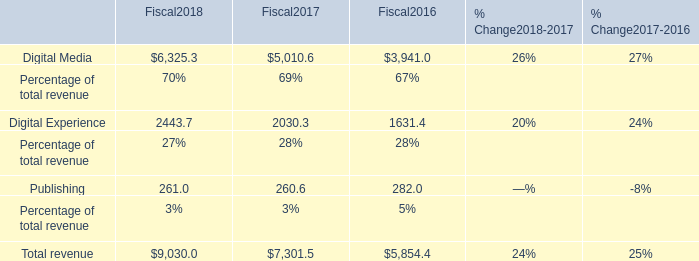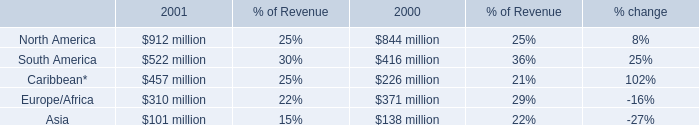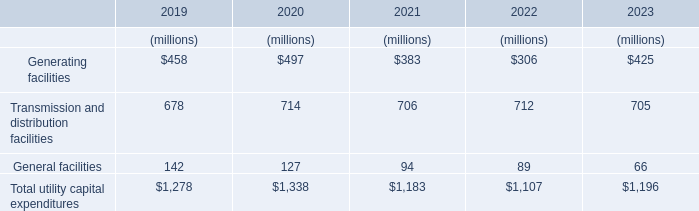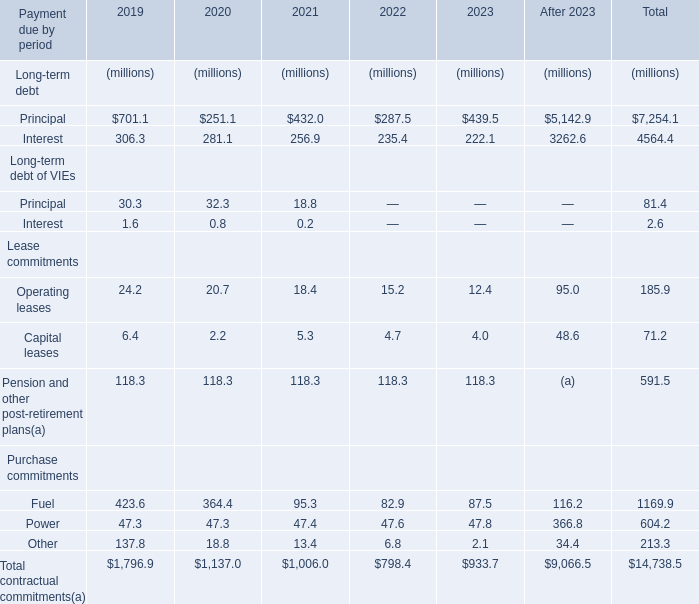What is the growing rate of General facilities in the year with the most Generating facilities? 
Computations: ((127 - 142) / 142)
Answer: -0.10563. 